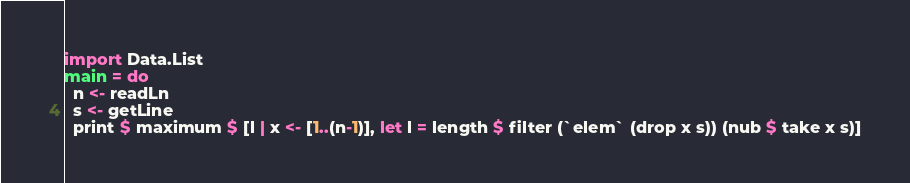Convert code to text. <code><loc_0><loc_0><loc_500><loc_500><_Haskell_>import Data.List
main = do
  n <- readLn
  s <- getLine
  print $ maximum $ [l | x <- [1..(n-1)], let l = length $ filter (`elem` (drop x s)) (nub $ take x s)]</code> 